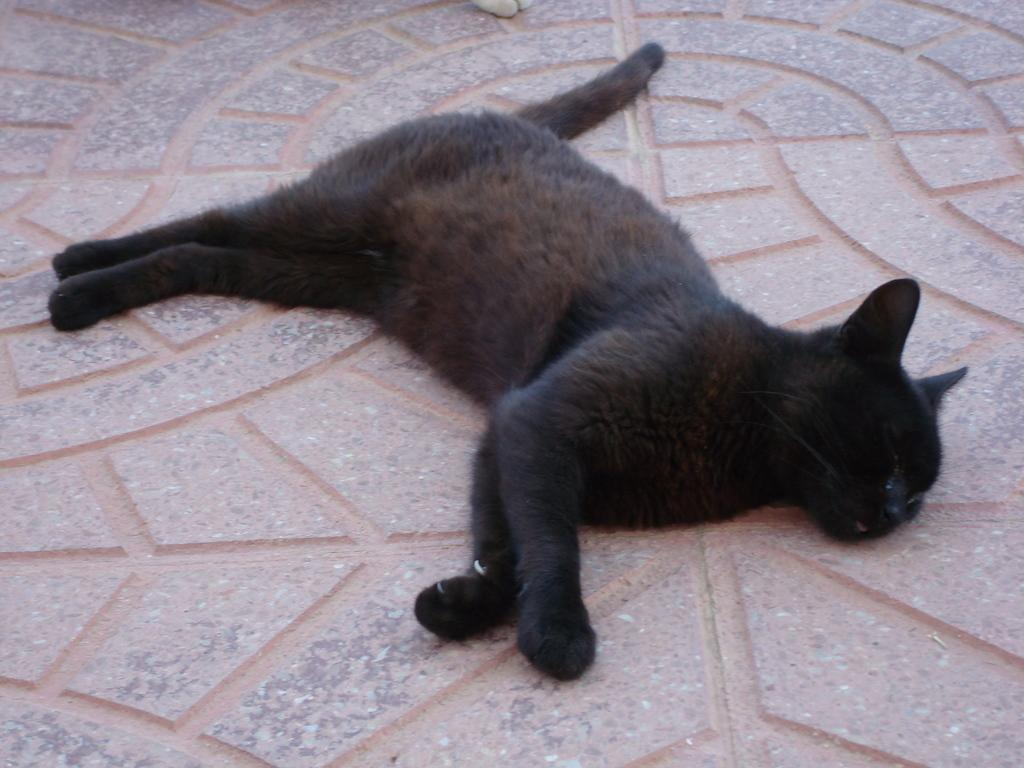What type of animal is in the image? There is a black cat in the image. What is the cat doing in the image? The cat is lying on the ground. How many times does the cat kiss the person in the image? There is no person present in the image, and therefore no kissing can be observed. 